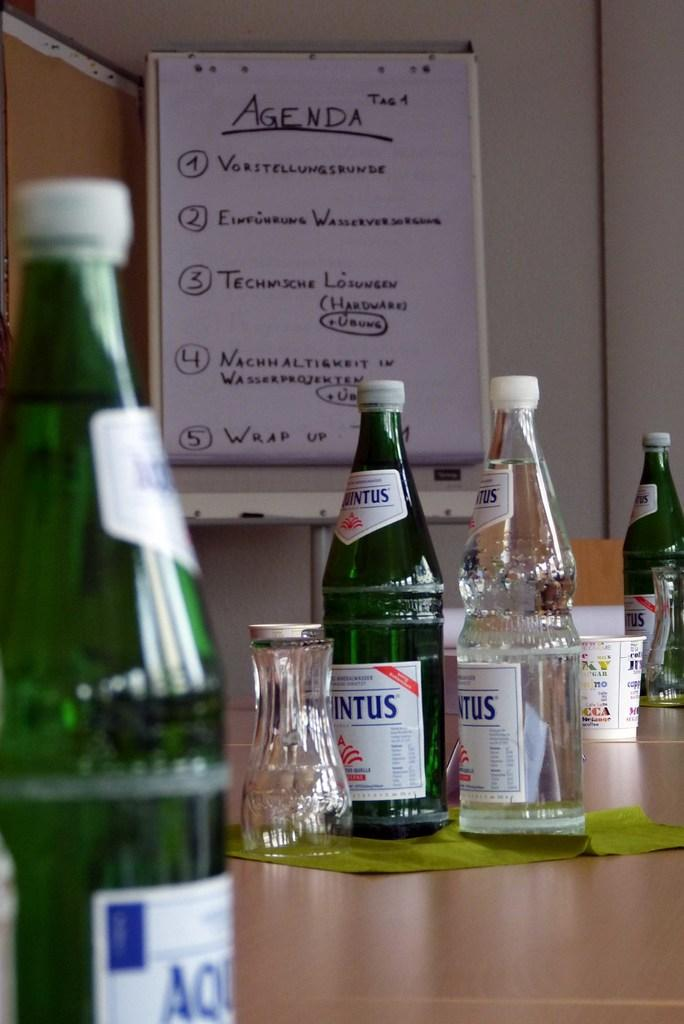<image>
Write a terse but informative summary of the picture. Several green bottles and glasses on a desk in front of an agenda paper. 